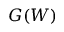Convert formula to latex. <formula><loc_0><loc_0><loc_500><loc_500>G ( W )</formula> 